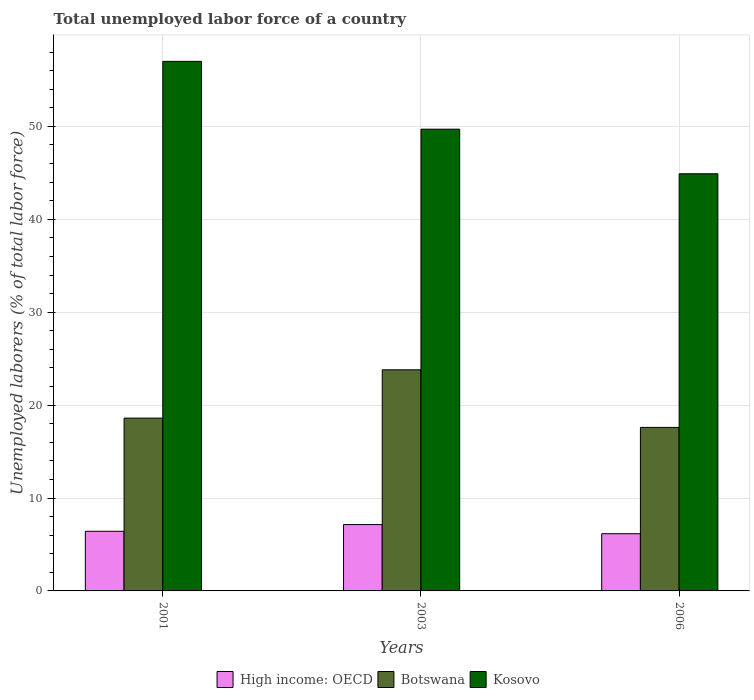How many groups of bars are there?
Ensure brevity in your answer.  3. Are the number of bars per tick equal to the number of legend labels?
Make the answer very short. Yes. How many bars are there on the 2nd tick from the left?
Your response must be concise. 3. How many bars are there on the 2nd tick from the right?
Your response must be concise. 3. In how many cases, is the number of bars for a given year not equal to the number of legend labels?
Keep it short and to the point. 0. What is the total unemployed labor force in Botswana in 2003?
Provide a short and direct response. 23.8. Across all years, what is the maximum total unemployed labor force in Botswana?
Provide a short and direct response. 23.8. Across all years, what is the minimum total unemployed labor force in Botswana?
Offer a terse response. 17.6. In which year was the total unemployed labor force in High income: OECD maximum?
Keep it short and to the point. 2003. In which year was the total unemployed labor force in Botswana minimum?
Provide a succinct answer. 2006. What is the total total unemployed labor force in High income: OECD in the graph?
Keep it short and to the point. 19.72. What is the difference between the total unemployed labor force in Kosovo in 2001 and that in 2006?
Make the answer very short. 12.1. What is the difference between the total unemployed labor force in Kosovo in 2001 and the total unemployed labor force in High income: OECD in 2006?
Ensure brevity in your answer.  50.84. What is the average total unemployed labor force in Botswana per year?
Give a very brief answer. 20. In the year 2003, what is the difference between the total unemployed labor force in High income: OECD and total unemployed labor force in Kosovo?
Your answer should be very brief. -42.56. What is the ratio of the total unemployed labor force in Botswana in 2001 to that in 2003?
Provide a short and direct response. 0.78. Is the total unemployed labor force in Kosovo in 2001 less than that in 2006?
Your answer should be compact. No. Is the difference between the total unemployed labor force in High income: OECD in 2003 and 2006 greater than the difference between the total unemployed labor force in Kosovo in 2003 and 2006?
Provide a succinct answer. No. What is the difference between the highest and the second highest total unemployed labor force in Kosovo?
Provide a succinct answer. 7.3. What is the difference between the highest and the lowest total unemployed labor force in High income: OECD?
Make the answer very short. 0.98. In how many years, is the total unemployed labor force in Kosovo greater than the average total unemployed labor force in Kosovo taken over all years?
Provide a short and direct response. 1. Is the sum of the total unemployed labor force in High income: OECD in 2003 and 2006 greater than the maximum total unemployed labor force in Kosovo across all years?
Give a very brief answer. No. What does the 3rd bar from the left in 2003 represents?
Provide a succinct answer. Kosovo. What does the 2nd bar from the right in 2006 represents?
Ensure brevity in your answer.  Botswana. Is it the case that in every year, the sum of the total unemployed labor force in Kosovo and total unemployed labor force in Botswana is greater than the total unemployed labor force in High income: OECD?
Provide a succinct answer. Yes. How many bars are there?
Provide a short and direct response. 9. How many years are there in the graph?
Keep it short and to the point. 3. What is the difference between two consecutive major ticks on the Y-axis?
Give a very brief answer. 10. Are the values on the major ticks of Y-axis written in scientific E-notation?
Your response must be concise. No. Does the graph contain grids?
Provide a short and direct response. Yes. Where does the legend appear in the graph?
Keep it short and to the point. Bottom center. How many legend labels are there?
Make the answer very short. 3. What is the title of the graph?
Offer a very short reply. Total unemployed labor force of a country. What is the label or title of the Y-axis?
Offer a terse response. Unemployed laborers (% of total labor force). What is the Unemployed laborers (% of total labor force) in High income: OECD in 2001?
Your answer should be very brief. 6.42. What is the Unemployed laborers (% of total labor force) of Botswana in 2001?
Your answer should be very brief. 18.6. What is the Unemployed laborers (% of total labor force) of High income: OECD in 2003?
Your answer should be compact. 7.14. What is the Unemployed laborers (% of total labor force) of Botswana in 2003?
Your answer should be very brief. 23.8. What is the Unemployed laborers (% of total labor force) in Kosovo in 2003?
Keep it short and to the point. 49.7. What is the Unemployed laborers (% of total labor force) in High income: OECD in 2006?
Your answer should be very brief. 6.16. What is the Unemployed laborers (% of total labor force) of Botswana in 2006?
Make the answer very short. 17.6. What is the Unemployed laborers (% of total labor force) in Kosovo in 2006?
Ensure brevity in your answer.  44.9. Across all years, what is the maximum Unemployed laborers (% of total labor force) in High income: OECD?
Keep it short and to the point. 7.14. Across all years, what is the maximum Unemployed laborers (% of total labor force) of Botswana?
Provide a short and direct response. 23.8. Across all years, what is the maximum Unemployed laborers (% of total labor force) in Kosovo?
Offer a terse response. 57. Across all years, what is the minimum Unemployed laborers (% of total labor force) in High income: OECD?
Give a very brief answer. 6.16. Across all years, what is the minimum Unemployed laborers (% of total labor force) of Botswana?
Provide a succinct answer. 17.6. Across all years, what is the minimum Unemployed laborers (% of total labor force) in Kosovo?
Keep it short and to the point. 44.9. What is the total Unemployed laborers (% of total labor force) of High income: OECD in the graph?
Make the answer very short. 19.72. What is the total Unemployed laborers (% of total labor force) of Botswana in the graph?
Ensure brevity in your answer.  60. What is the total Unemployed laborers (% of total labor force) of Kosovo in the graph?
Provide a short and direct response. 151.6. What is the difference between the Unemployed laborers (% of total labor force) in High income: OECD in 2001 and that in 2003?
Give a very brief answer. -0.72. What is the difference between the Unemployed laborers (% of total labor force) of Botswana in 2001 and that in 2003?
Your answer should be compact. -5.2. What is the difference between the Unemployed laborers (% of total labor force) of Kosovo in 2001 and that in 2003?
Keep it short and to the point. 7.3. What is the difference between the Unemployed laborers (% of total labor force) of High income: OECD in 2001 and that in 2006?
Your answer should be compact. 0.26. What is the difference between the Unemployed laborers (% of total labor force) in Botswana in 2001 and that in 2006?
Ensure brevity in your answer.  1. What is the difference between the Unemployed laborers (% of total labor force) of Kosovo in 2001 and that in 2006?
Your answer should be very brief. 12.1. What is the difference between the Unemployed laborers (% of total labor force) in High income: OECD in 2003 and that in 2006?
Keep it short and to the point. 0.98. What is the difference between the Unemployed laborers (% of total labor force) in High income: OECD in 2001 and the Unemployed laborers (% of total labor force) in Botswana in 2003?
Provide a succinct answer. -17.38. What is the difference between the Unemployed laborers (% of total labor force) of High income: OECD in 2001 and the Unemployed laborers (% of total labor force) of Kosovo in 2003?
Make the answer very short. -43.28. What is the difference between the Unemployed laborers (% of total labor force) of Botswana in 2001 and the Unemployed laborers (% of total labor force) of Kosovo in 2003?
Offer a very short reply. -31.1. What is the difference between the Unemployed laborers (% of total labor force) in High income: OECD in 2001 and the Unemployed laborers (% of total labor force) in Botswana in 2006?
Your answer should be very brief. -11.18. What is the difference between the Unemployed laborers (% of total labor force) of High income: OECD in 2001 and the Unemployed laborers (% of total labor force) of Kosovo in 2006?
Your answer should be compact. -38.48. What is the difference between the Unemployed laborers (% of total labor force) of Botswana in 2001 and the Unemployed laborers (% of total labor force) of Kosovo in 2006?
Your response must be concise. -26.3. What is the difference between the Unemployed laborers (% of total labor force) in High income: OECD in 2003 and the Unemployed laborers (% of total labor force) in Botswana in 2006?
Offer a terse response. -10.46. What is the difference between the Unemployed laborers (% of total labor force) of High income: OECD in 2003 and the Unemployed laborers (% of total labor force) of Kosovo in 2006?
Ensure brevity in your answer.  -37.76. What is the difference between the Unemployed laborers (% of total labor force) in Botswana in 2003 and the Unemployed laborers (% of total labor force) in Kosovo in 2006?
Provide a short and direct response. -21.1. What is the average Unemployed laborers (% of total labor force) in High income: OECD per year?
Offer a very short reply. 6.57. What is the average Unemployed laborers (% of total labor force) in Botswana per year?
Provide a short and direct response. 20. What is the average Unemployed laborers (% of total labor force) of Kosovo per year?
Your answer should be compact. 50.53. In the year 2001, what is the difference between the Unemployed laborers (% of total labor force) in High income: OECD and Unemployed laborers (% of total labor force) in Botswana?
Your answer should be very brief. -12.18. In the year 2001, what is the difference between the Unemployed laborers (% of total labor force) of High income: OECD and Unemployed laborers (% of total labor force) of Kosovo?
Your answer should be very brief. -50.58. In the year 2001, what is the difference between the Unemployed laborers (% of total labor force) of Botswana and Unemployed laborers (% of total labor force) of Kosovo?
Ensure brevity in your answer.  -38.4. In the year 2003, what is the difference between the Unemployed laborers (% of total labor force) in High income: OECD and Unemployed laborers (% of total labor force) in Botswana?
Your answer should be very brief. -16.66. In the year 2003, what is the difference between the Unemployed laborers (% of total labor force) in High income: OECD and Unemployed laborers (% of total labor force) in Kosovo?
Offer a very short reply. -42.56. In the year 2003, what is the difference between the Unemployed laborers (% of total labor force) of Botswana and Unemployed laborers (% of total labor force) of Kosovo?
Offer a very short reply. -25.9. In the year 2006, what is the difference between the Unemployed laborers (% of total labor force) in High income: OECD and Unemployed laborers (% of total labor force) in Botswana?
Your answer should be very brief. -11.44. In the year 2006, what is the difference between the Unemployed laborers (% of total labor force) of High income: OECD and Unemployed laborers (% of total labor force) of Kosovo?
Give a very brief answer. -38.74. In the year 2006, what is the difference between the Unemployed laborers (% of total labor force) in Botswana and Unemployed laborers (% of total labor force) in Kosovo?
Provide a succinct answer. -27.3. What is the ratio of the Unemployed laborers (% of total labor force) in High income: OECD in 2001 to that in 2003?
Your answer should be compact. 0.9. What is the ratio of the Unemployed laborers (% of total labor force) in Botswana in 2001 to that in 2003?
Ensure brevity in your answer.  0.78. What is the ratio of the Unemployed laborers (% of total labor force) of Kosovo in 2001 to that in 2003?
Ensure brevity in your answer.  1.15. What is the ratio of the Unemployed laborers (% of total labor force) in High income: OECD in 2001 to that in 2006?
Keep it short and to the point. 1.04. What is the ratio of the Unemployed laborers (% of total labor force) of Botswana in 2001 to that in 2006?
Give a very brief answer. 1.06. What is the ratio of the Unemployed laborers (% of total labor force) in Kosovo in 2001 to that in 2006?
Your answer should be compact. 1.27. What is the ratio of the Unemployed laborers (% of total labor force) of High income: OECD in 2003 to that in 2006?
Keep it short and to the point. 1.16. What is the ratio of the Unemployed laborers (% of total labor force) in Botswana in 2003 to that in 2006?
Ensure brevity in your answer.  1.35. What is the ratio of the Unemployed laborers (% of total labor force) of Kosovo in 2003 to that in 2006?
Keep it short and to the point. 1.11. What is the difference between the highest and the second highest Unemployed laborers (% of total labor force) of High income: OECD?
Provide a short and direct response. 0.72. What is the difference between the highest and the second highest Unemployed laborers (% of total labor force) of Botswana?
Provide a succinct answer. 5.2. What is the difference between the highest and the lowest Unemployed laborers (% of total labor force) in High income: OECD?
Offer a terse response. 0.98. 